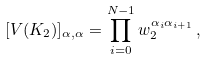<formula> <loc_0><loc_0><loc_500><loc_500>[ V ( K _ { 2 } ) ] _ { \alpha , \alpha } = \prod _ { i = 0 } ^ { N - 1 } { w _ { 2 } ^ { \alpha _ { i } \alpha _ { i + 1 } } } \, ,</formula> 